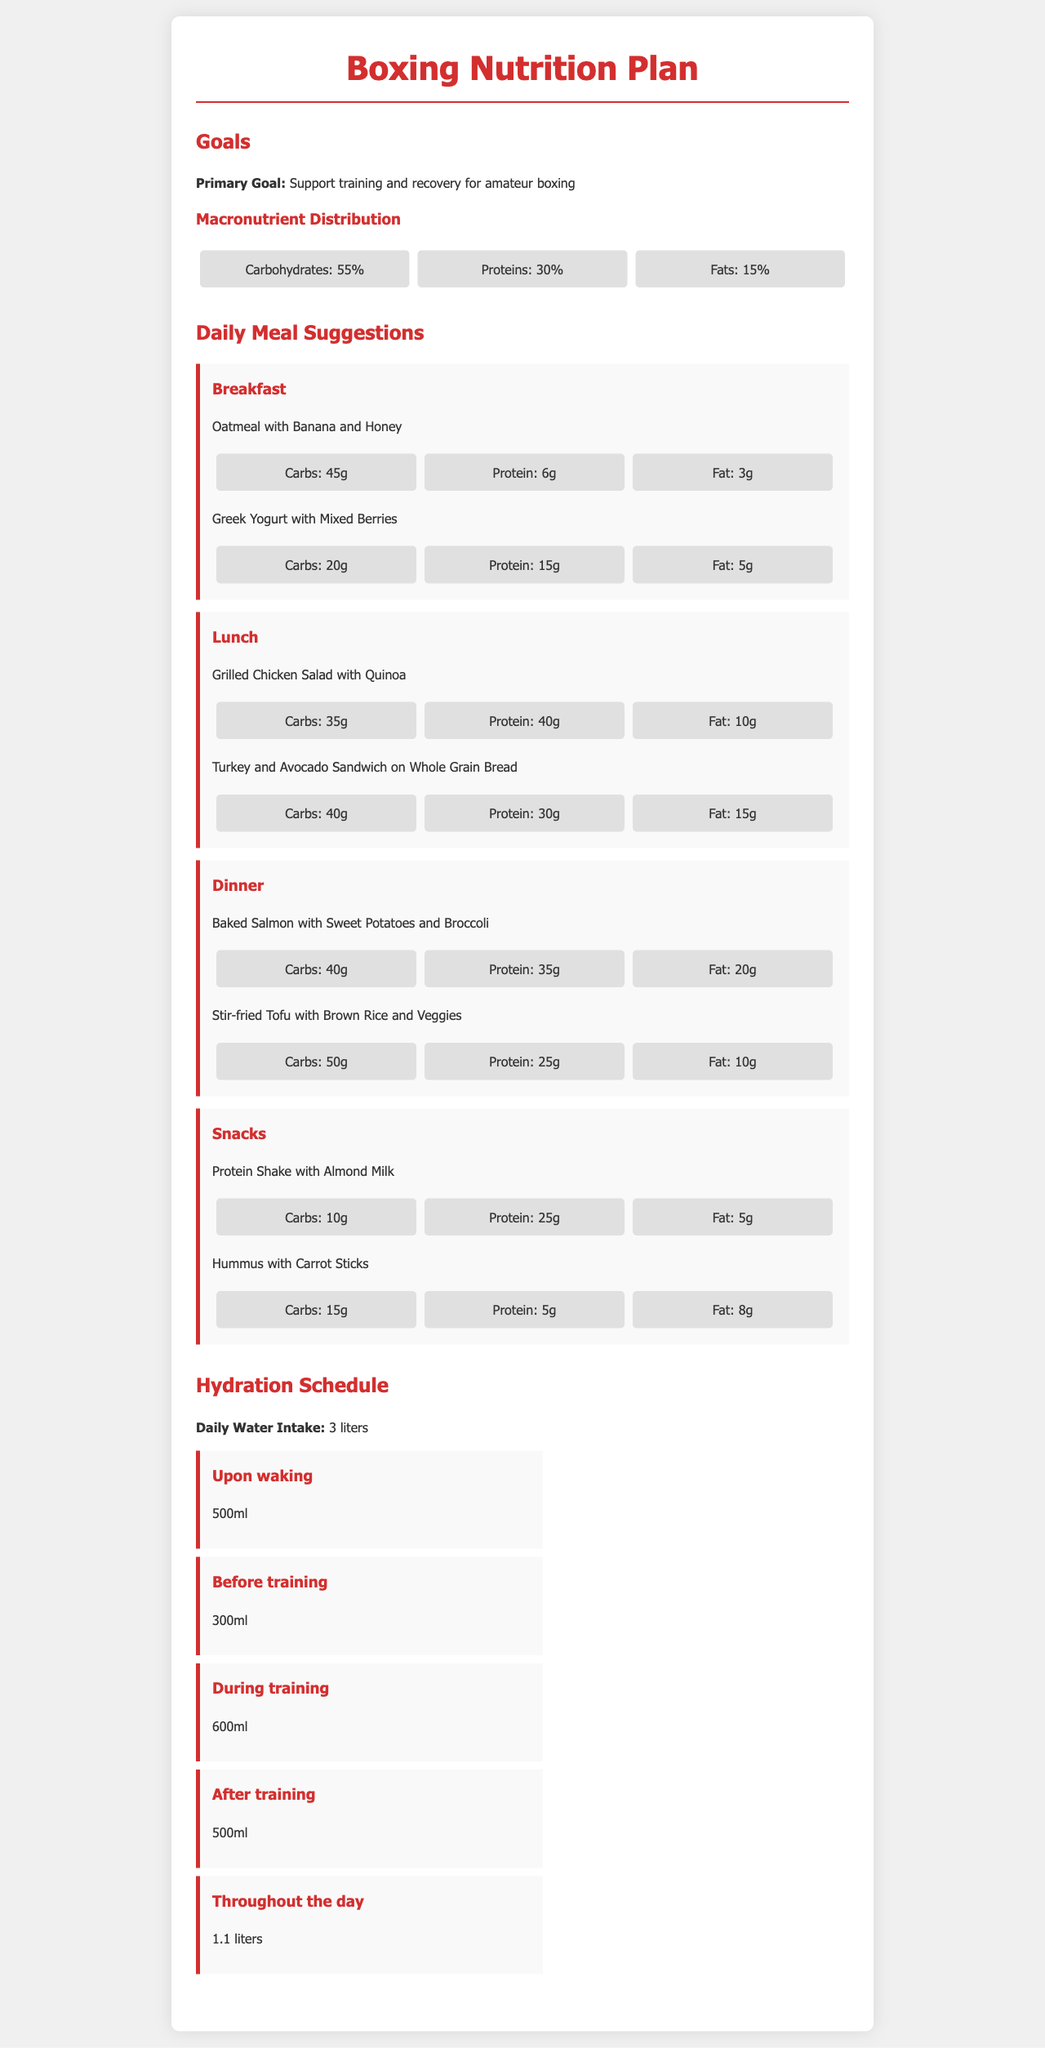What is the primary goal of the nutrition plan? The document states that the primary goal is to support training and recovery for amateur boxing.
Answer: Support training and recovery for amateur boxing What percentage of the diet should come from carbohydrates? The document specifies that carbohydrates should constitute 55% of the diet.
Answer: 55% What is included in the breakfast section? The breakfast section lists Oatmeal with Banana and Honey and Greek Yogurt with Mixed Berries.
Answer: Oatmeal with Banana and Honey; Greek Yogurt with Mixed Berries How much protein is in the Grilled Chicken Salad with Quinoa? The Grilled Chicken Salad with Quinoa has a protein content of 40g as per the document.
Answer: 40g What is the total daily water intake suggested? The document mentions that the daily water intake should be 3 liters.
Answer: 3 liters How much water should be consumed before training? The document states that 300ml should be consumed before training.
Answer: 300ml What percentage of the diet is allocated for fats? The macronutrient distribution indicates that fats should comprise 15% of the diet.
Answer: 15% What snack item contains the highest protein content? The Protein Shake with Almond Milk contains the highest protein content at 25g.
Answer: Protein Shake with Almond Milk How much water should be consumed throughout the day? The hydration schedule suggests consuming 1.1 liters throughout the day.
Answer: 1.1 liters 